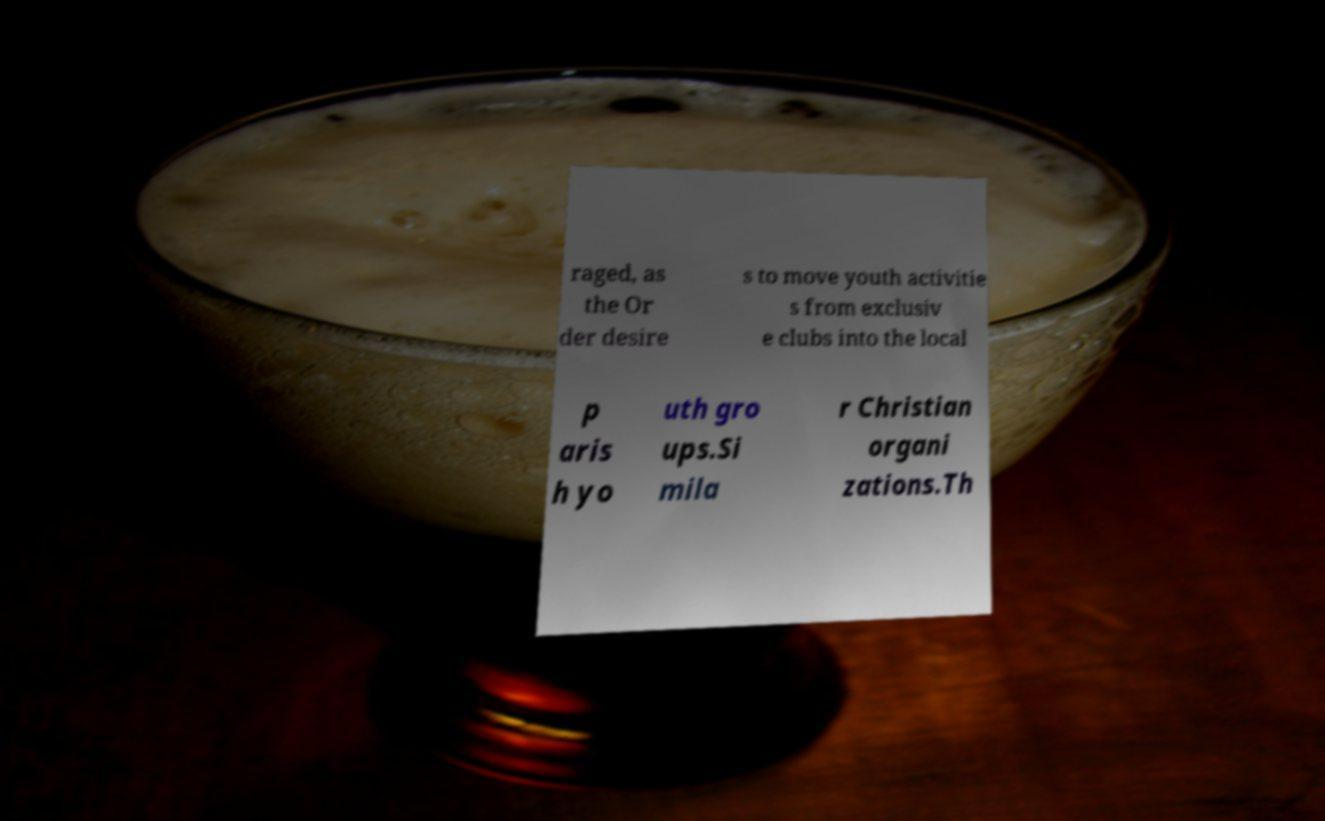What messages or text are displayed in this image? I need them in a readable, typed format. raged, as the Or der desire s to move youth activitie s from exclusiv e clubs into the local p aris h yo uth gro ups.Si mila r Christian organi zations.Th 